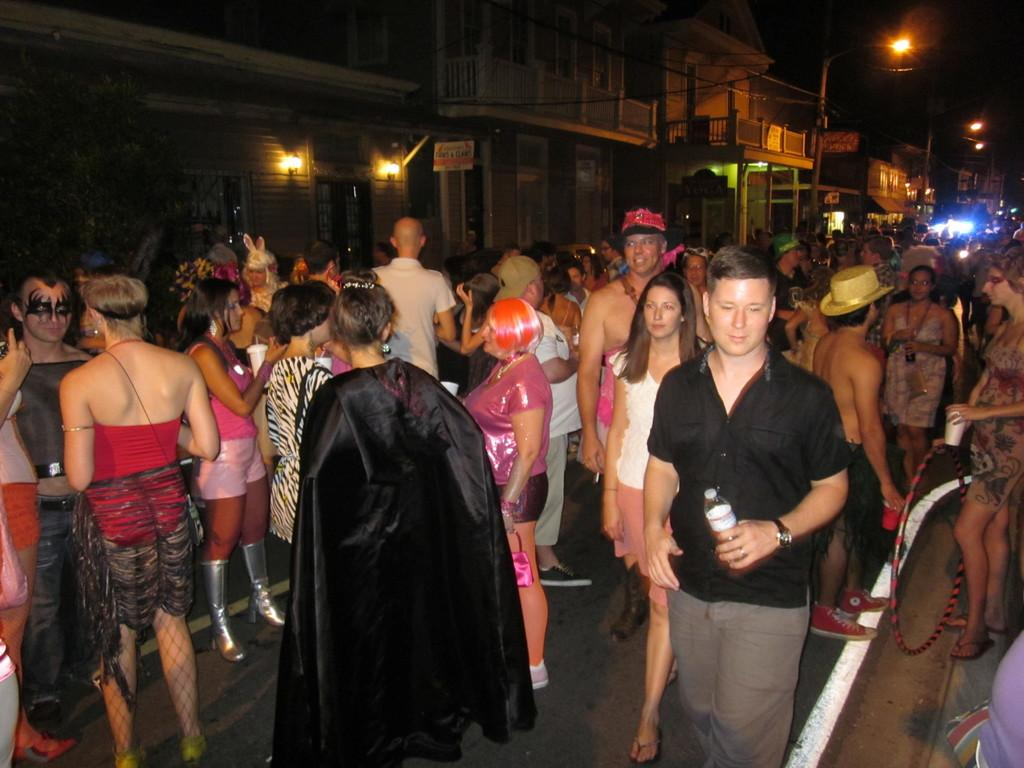What is the lighting condition in the image? The image was taken in a dark environment. What can be seen in the foreground of the image? There is a crowd of people in the image. Where are the people standing? The people are standing on a road. What is visible in the background of the image? There are buildings and light poles in the background of the image. How much dirt is visible on the road in the image? There is no dirt visible on the road in the image; it appears to be clean. What type of love is being expressed by the people in the image? There is no indication of love being expressed in the image; it simply shows a crowd of people standing on a road. 